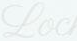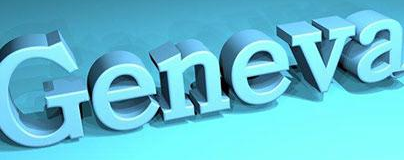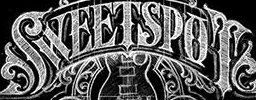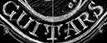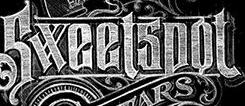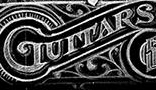Transcribe the words shown in these images in order, separated by a semicolon. Loc; Geneva; SWEETSPOT; GUITARS; Sweetspot; GUITARS 